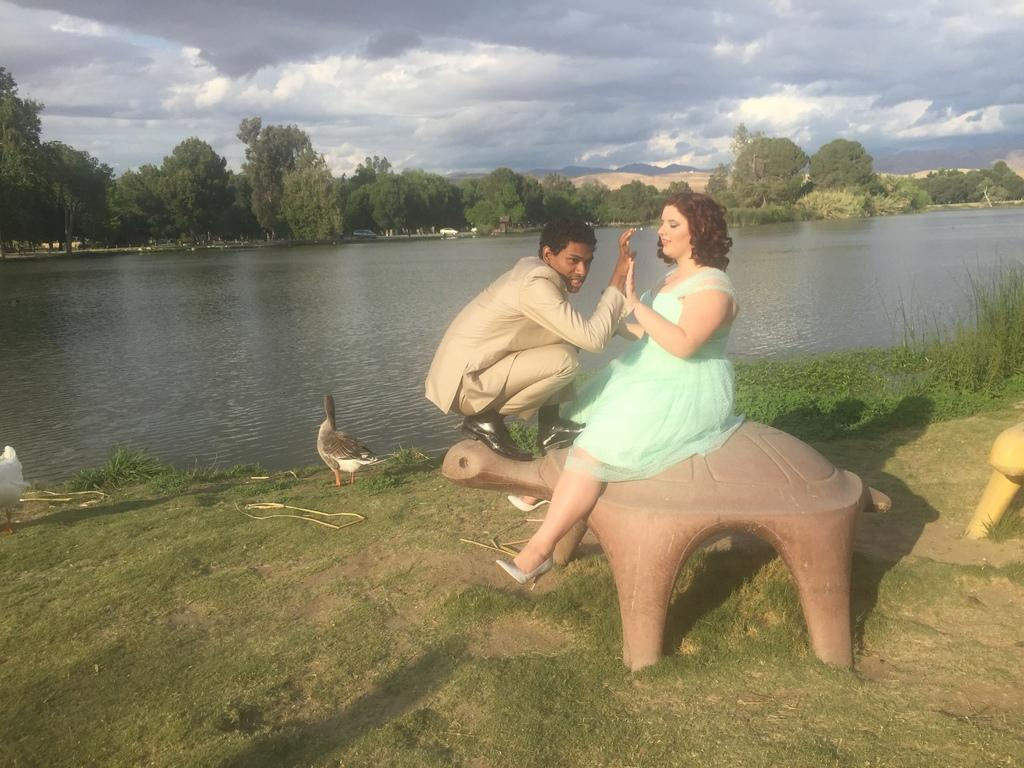How many people are in the image? There is a man and a woman in the image. What is the woman doing in the image? The woman is seated in the image. What animal is in front of the man and woman? There is a duck in front of the man and woman. What can be seen in the background of the image? Water, trees, clouds, and plants can be seen in the background of the image. What type of oil can be seen in the image? There is no oil present in the image. Is there a judge in the image? There is no judge present in the image. 